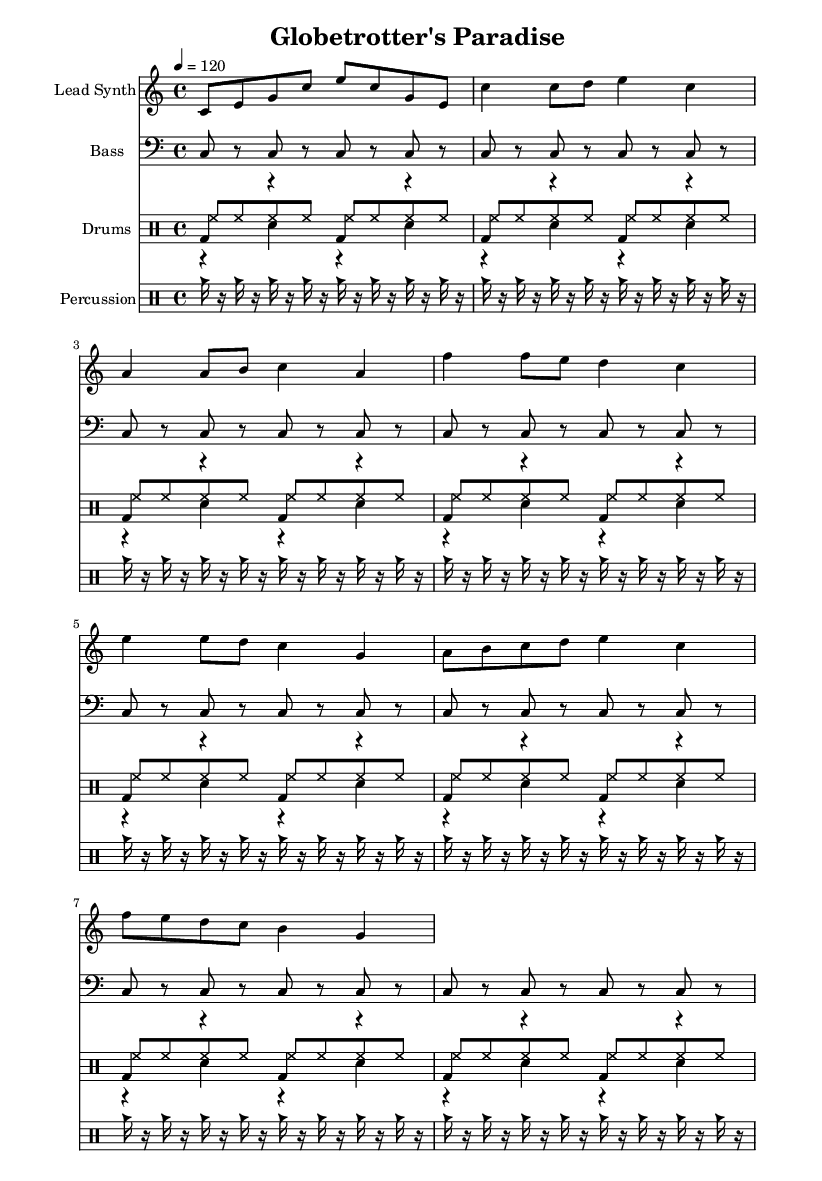What is the key signature of this music? The key signature is C major, which is indicated at the beginning of the staff with no sharps or flats in the signature.
Answer: C major What is the time signature of this music? The time signature is 4/4, visible at the beginning of the sheet music, indicating four beats per measure with a quarter note receiving one beat.
Answer: 4/4 What is the tempo of this piece? The tempo is set at 120 beats per minute, as indicated by the tempo marking at the beginning of the score.
Answer: 120 How many measures are there in the lead synth part? The lead synth part consists of 8 measures, as displayed in the notation from the beginning to the end of its section.
Answer: 8 What is the primary style of this music? The music is an upbeat rap style, noticeable through its rhythmic patterns and lyrical flow that would complement a travel theme.
Answer: Upbeat rap What is the rhythmic pattern of the kick drum? The kick drum plays a repetitive pattern of bass drum hits on the downbeat, consistently every measure, suggesting a strong driving rhythm typical in rap music.
Answer: Repetitive bass What instruments are indicated in this score? The score includes lead synth, bass, kick drum, snare drum, hi-hat, and percussion, outlining the arrangement used in this travel-themed rap.
Answer: Lead synth, bass, drums, percussion 